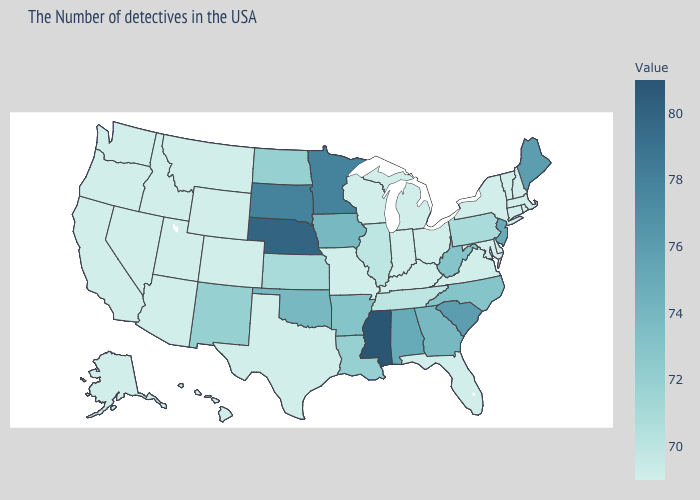Which states have the lowest value in the USA?
Concise answer only. Massachusetts, Rhode Island, New Hampshire, Vermont, Connecticut, New York, Delaware, Maryland, Virginia, Ohio, Florida, Michigan, Kentucky, Indiana, Wisconsin, Missouri, Texas, Wyoming, Colorado, Utah, Montana, Arizona, Idaho, Nevada, California, Washington, Oregon, Alaska, Hawaii. Among the states that border Kentucky , does West Virginia have the lowest value?
Give a very brief answer. No. Does Minnesota have a lower value than Nebraska?
Give a very brief answer. Yes. 